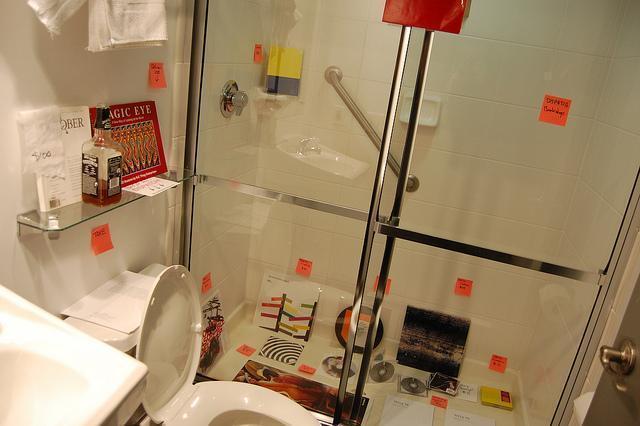What is near the bottle of alcohol?
Select the accurate response from the four choices given to answer the question.
Options: Toilet, whistle, man, bunny. Toilet. 